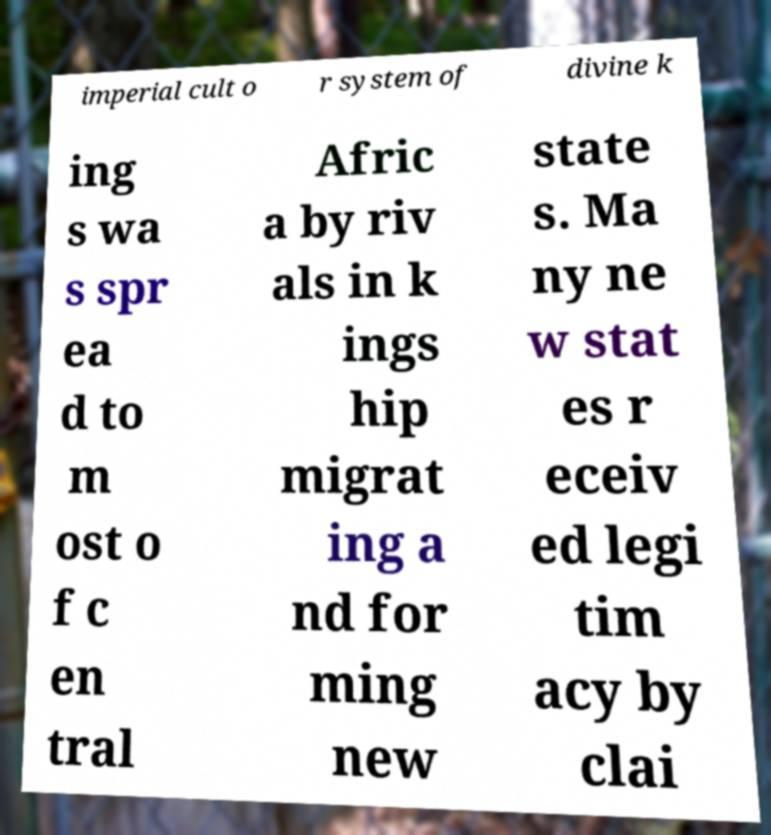Please read and relay the text visible in this image. What does it say? imperial cult o r system of divine k ing s wa s spr ea d to m ost o f c en tral Afric a by riv als in k ings hip migrat ing a nd for ming new state s. Ma ny ne w stat es r eceiv ed legi tim acy by clai 